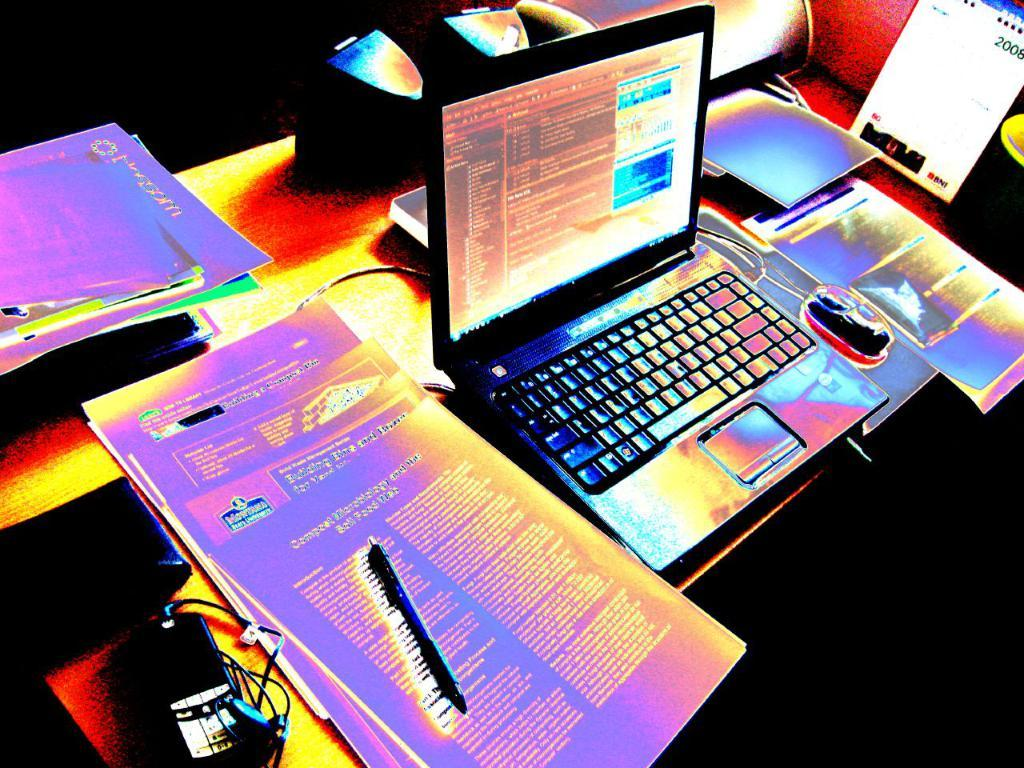<image>
Relay a brief, clear account of the picture shown. A phone showing 2008 is on the side of a laptop and stacks of papers. 